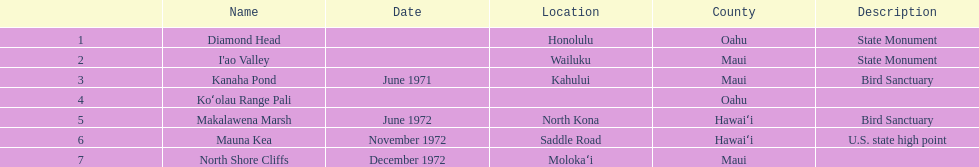What are the total number of landmarks located in maui? 3. 